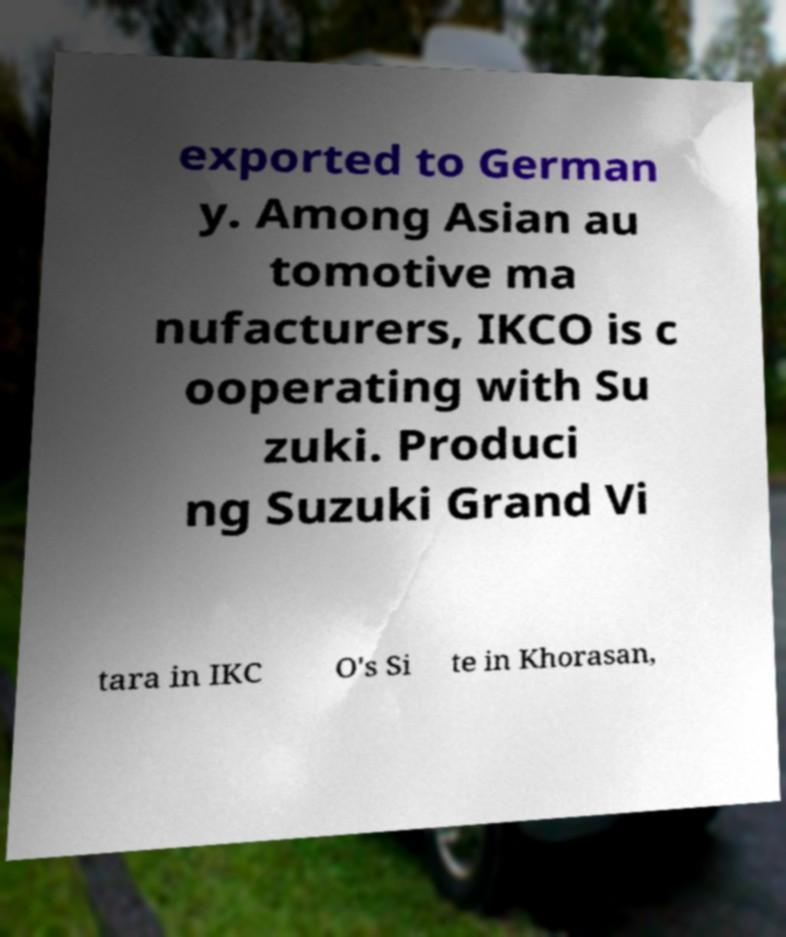Please read and relay the text visible in this image. What does it say? exported to German y. Among Asian au tomotive ma nufacturers, IKCO is c ooperating with Su zuki. Produci ng Suzuki Grand Vi tara in IKC O's Si te in Khorasan, 